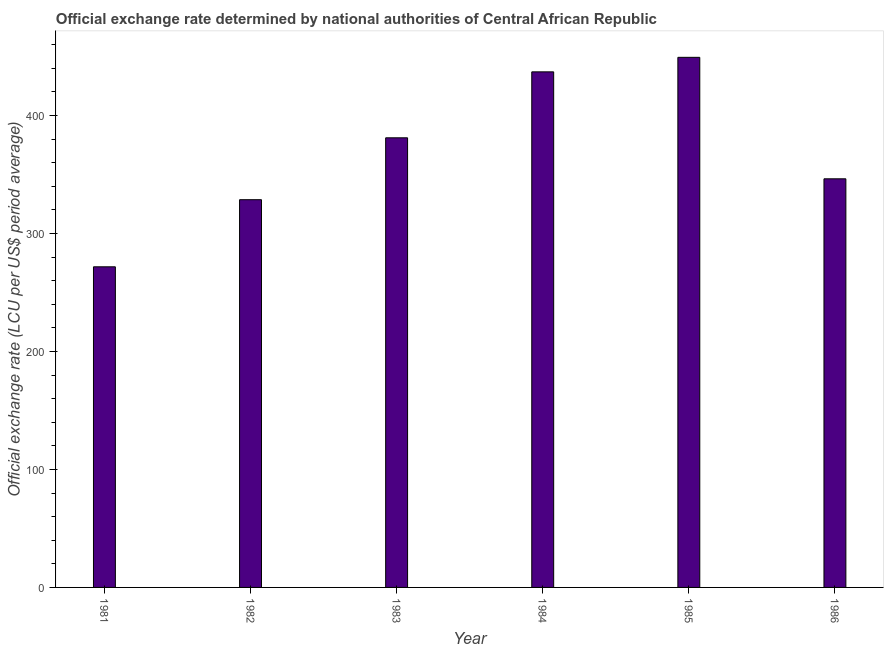Does the graph contain grids?
Offer a very short reply. No. What is the title of the graph?
Offer a very short reply. Official exchange rate determined by national authorities of Central African Republic. What is the label or title of the Y-axis?
Make the answer very short. Official exchange rate (LCU per US$ period average). What is the official exchange rate in 1984?
Give a very brief answer. 436.96. Across all years, what is the maximum official exchange rate?
Your answer should be very brief. 449.26. Across all years, what is the minimum official exchange rate?
Provide a succinct answer. 271.73. In which year was the official exchange rate maximum?
Give a very brief answer. 1985. What is the sum of the official exchange rate?
Make the answer very short. 2213.93. What is the difference between the official exchange rate in 1983 and 1984?
Provide a succinct answer. -55.89. What is the average official exchange rate per year?
Make the answer very short. 368.99. What is the median official exchange rate?
Offer a terse response. 363.69. What is the ratio of the official exchange rate in 1982 to that in 1986?
Provide a succinct answer. 0.95. What is the difference between the highest and the second highest official exchange rate?
Your response must be concise. 12.31. Is the sum of the official exchange rate in 1981 and 1984 greater than the maximum official exchange rate across all years?
Offer a very short reply. Yes. What is the difference between the highest and the lowest official exchange rate?
Ensure brevity in your answer.  177.53. How many bars are there?
Make the answer very short. 6. Are the values on the major ticks of Y-axis written in scientific E-notation?
Your answer should be compact. No. What is the Official exchange rate (LCU per US$ period average) of 1981?
Offer a very short reply. 271.73. What is the Official exchange rate (LCU per US$ period average) of 1982?
Your answer should be very brief. 328.61. What is the Official exchange rate (LCU per US$ period average) in 1983?
Give a very brief answer. 381.07. What is the Official exchange rate (LCU per US$ period average) in 1984?
Ensure brevity in your answer.  436.96. What is the Official exchange rate (LCU per US$ period average) of 1985?
Offer a terse response. 449.26. What is the Official exchange rate (LCU per US$ period average) of 1986?
Your answer should be very brief. 346.31. What is the difference between the Official exchange rate (LCU per US$ period average) in 1981 and 1982?
Offer a terse response. -56.87. What is the difference between the Official exchange rate (LCU per US$ period average) in 1981 and 1983?
Ensure brevity in your answer.  -109.33. What is the difference between the Official exchange rate (LCU per US$ period average) in 1981 and 1984?
Offer a very short reply. -165.23. What is the difference between the Official exchange rate (LCU per US$ period average) in 1981 and 1985?
Your answer should be compact. -177.53. What is the difference between the Official exchange rate (LCU per US$ period average) in 1981 and 1986?
Your response must be concise. -74.57. What is the difference between the Official exchange rate (LCU per US$ period average) in 1982 and 1983?
Offer a terse response. -52.46. What is the difference between the Official exchange rate (LCU per US$ period average) in 1982 and 1984?
Provide a short and direct response. -108.35. What is the difference between the Official exchange rate (LCU per US$ period average) in 1982 and 1985?
Make the answer very short. -120.66. What is the difference between the Official exchange rate (LCU per US$ period average) in 1982 and 1986?
Offer a very short reply. -17.7. What is the difference between the Official exchange rate (LCU per US$ period average) in 1983 and 1984?
Provide a short and direct response. -55.89. What is the difference between the Official exchange rate (LCU per US$ period average) in 1983 and 1985?
Provide a succinct answer. -68.2. What is the difference between the Official exchange rate (LCU per US$ period average) in 1983 and 1986?
Provide a short and direct response. 34.76. What is the difference between the Official exchange rate (LCU per US$ period average) in 1984 and 1985?
Ensure brevity in your answer.  -12.31. What is the difference between the Official exchange rate (LCU per US$ period average) in 1984 and 1986?
Provide a short and direct response. 90.65. What is the difference between the Official exchange rate (LCU per US$ period average) in 1985 and 1986?
Offer a very short reply. 102.96. What is the ratio of the Official exchange rate (LCU per US$ period average) in 1981 to that in 1982?
Your response must be concise. 0.83. What is the ratio of the Official exchange rate (LCU per US$ period average) in 1981 to that in 1983?
Your answer should be very brief. 0.71. What is the ratio of the Official exchange rate (LCU per US$ period average) in 1981 to that in 1984?
Keep it short and to the point. 0.62. What is the ratio of the Official exchange rate (LCU per US$ period average) in 1981 to that in 1985?
Give a very brief answer. 0.6. What is the ratio of the Official exchange rate (LCU per US$ period average) in 1981 to that in 1986?
Offer a terse response. 0.79. What is the ratio of the Official exchange rate (LCU per US$ period average) in 1982 to that in 1983?
Your response must be concise. 0.86. What is the ratio of the Official exchange rate (LCU per US$ period average) in 1982 to that in 1984?
Provide a succinct answer. 0.75. What is the ratio of the Official exchange rate (LCU per US$ period average) in 1982 to that in 1985?
Provide a succinct answer. 0.73. What is the ratio of the Official exchange rate (LCU per US$ period average) in 1982 to that in 1986?
Offer a terse response. 0.95. What is the ratio of the Official exchange rate (LCU per US$ period average) in 1983 to that in 1984?
Provide a succinct answer. 0.87. What is the ratio of the Official exchange rate (LCU per US$ period average) in 1983 to that in 1985?
Provide a succinct answer. 0.85. What is the ratio of the Official exchange rate (LCU per US$ period average) in 1984 to that in 1985?
Ensure brevity in your answer.  0.97. What is the ratio of the Official exchange rate (LCU per US$ period average) in 1984 to that in 1986?
Your answer should be compact. 1.26. What is the ratio of the Official exchange rate (LCU per US$ period average) in 1985 to that in 1986?
Give a very brief answer. 1.3. 